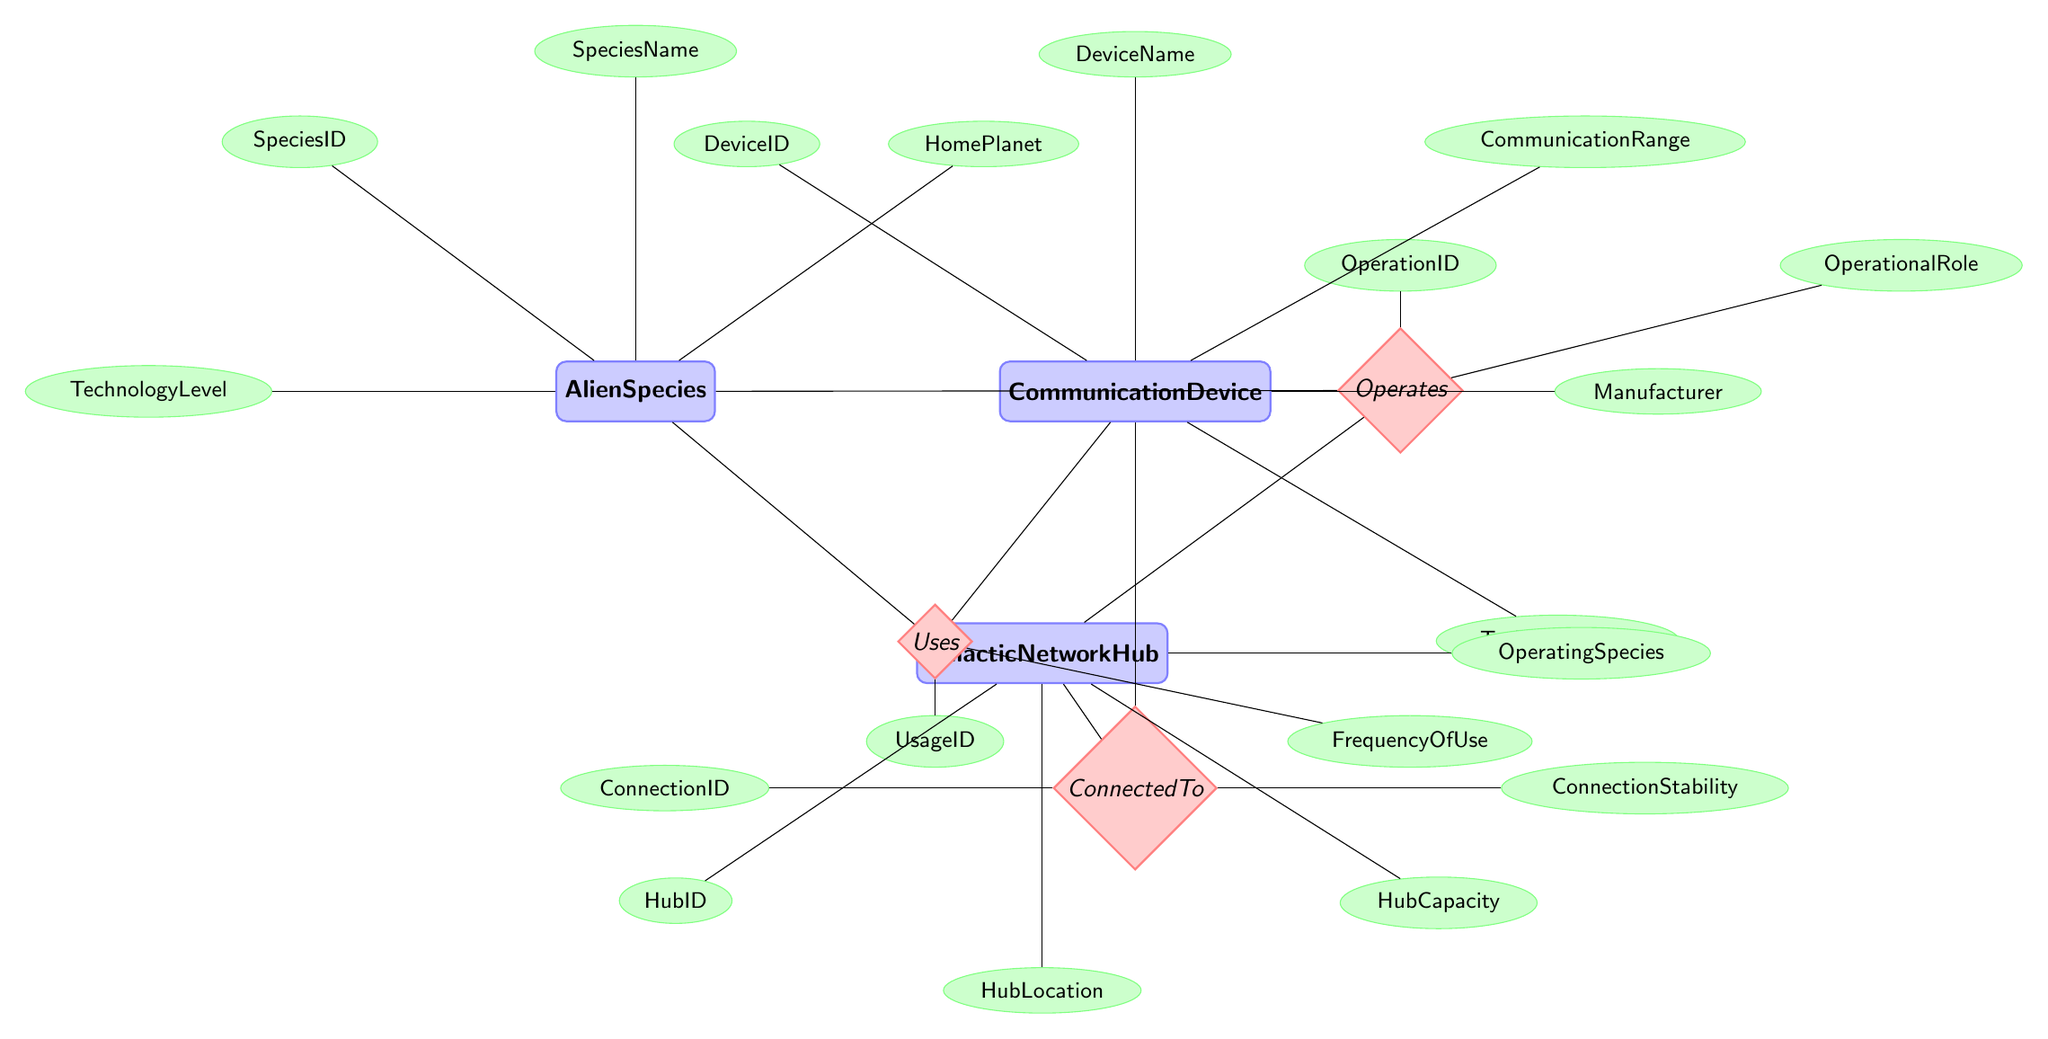What is the name of the entity representing different alien communities? The entity that represents different alien communities is "AlienSpecies".
Answer: AlienSpecies How many attributes does the CommunicationDevice entity have? The CommunicationDevice entity has five attributes: DeviceID, DeviceName, CommunicationRange, Manufacturer, and TechnologyUsed.
Answer: 5 What relationship connects AlienSpecies to CommunicationDevice? The relationship that connects AlienSpecies to CommunicationDevice is "Uses".
Answer: Uses Which entity has the attribute "HubLocation"? The entity that has the attribute "HubLocation" is "GalacticNetworkHub".
Answer: GalacticNetworkHub What is the OperationalRole attributed to the relationship "Operates"? The relationship "Operates" has the attribute "OperationalRole" associated with it, detailing the role of the alien species in relation to the galactic network hub.
Answer: OperationalRole How many relationships are depicted in the diagram? There are three relationships illustrated in the diagram: Uses, ConnectedTo, and Operates.
Answer: 3 Which entities are connected by the "ConnectedTo" relationship? The "ConnectedTo" relationship connects the entities "CommunicationDevice" and "GalacticNetworkHub".
Answer: CommunicationDevice and GalacticNetworkHub What are the names of the entities involved in the "Uses" relationship? The "Uses" relationship involves the entities "AlienSpecies" and "CommunicationDevice".
Answer: AlienSpecies and CommunicationDevice Which attribute specifies the stability of the connection in the "ConnectedTo" relationship? The "ConnectionStability" attribute specifies the stability of the connection in the "ConnectedTo" relationship.
Answer: ConnectionStability 